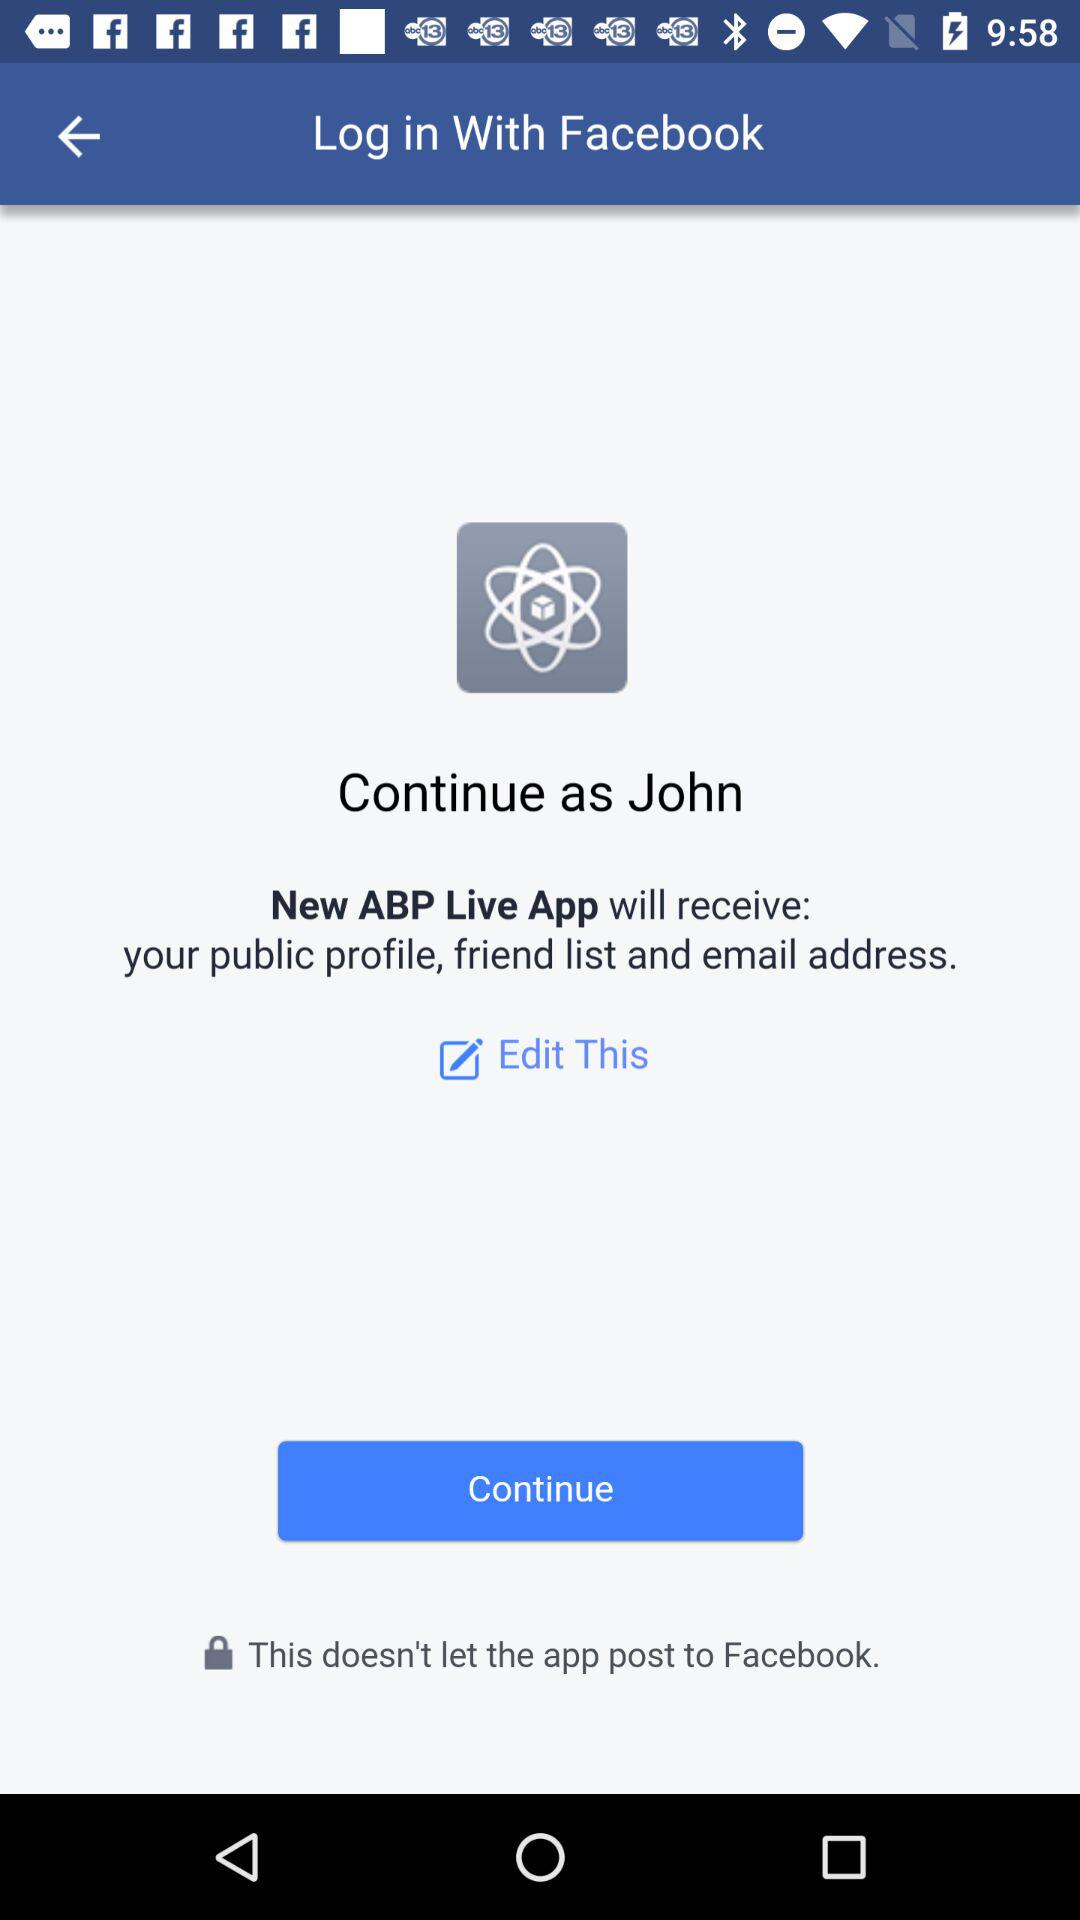What is the user name? The user name is John. 